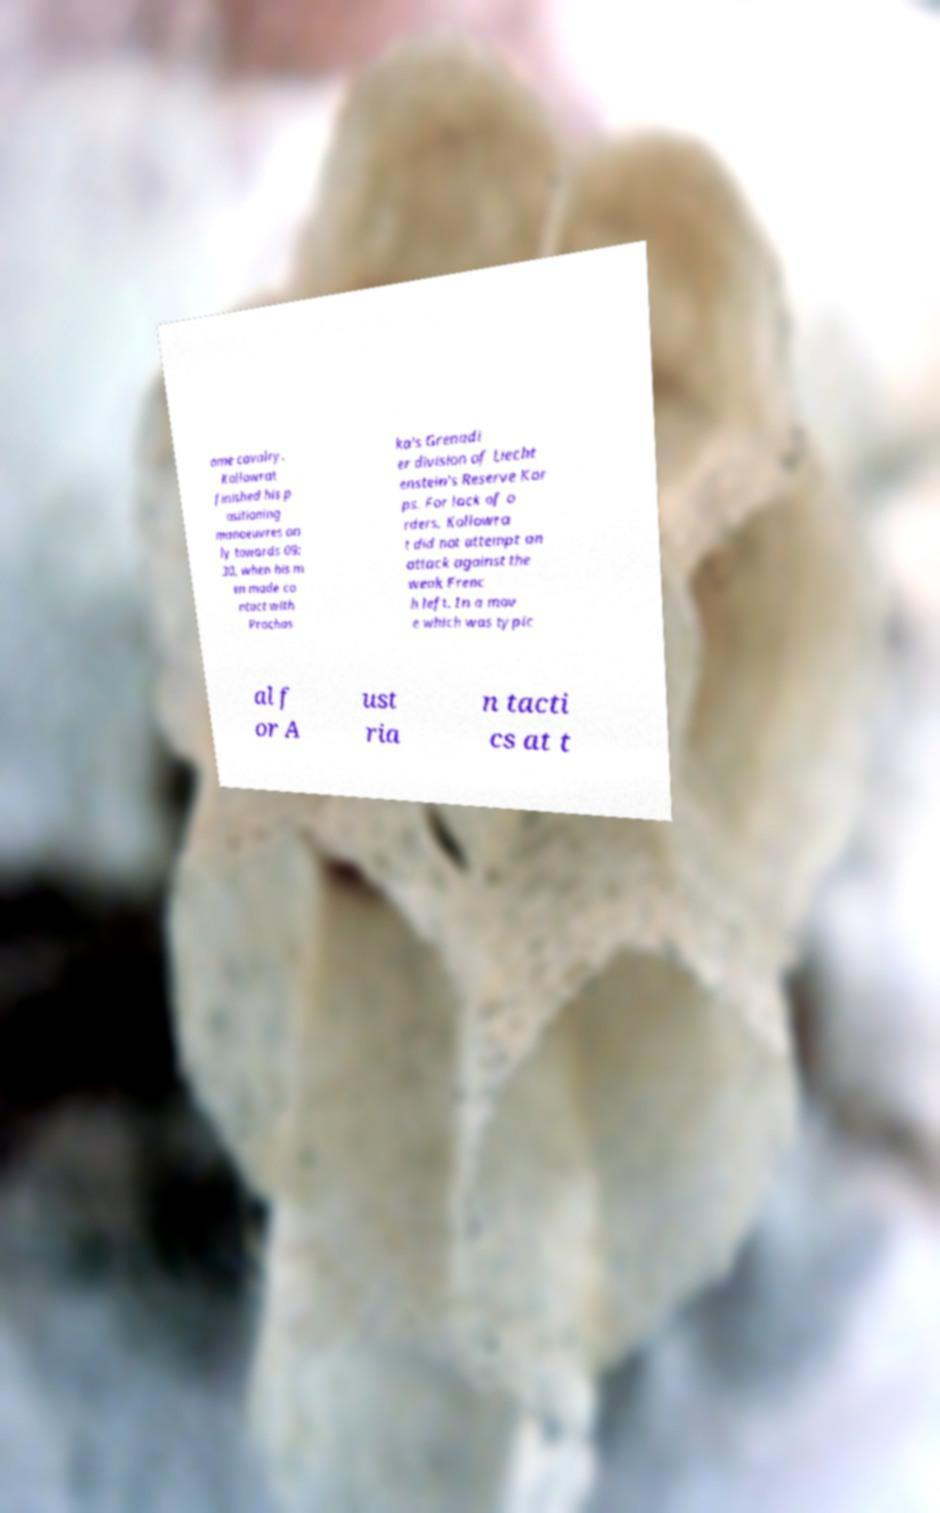Please identify and transcribe the text found in this image. ome cavalry. Kollowrat finished his p ositioning manoeuvres on ly towards 09: 30, when his m en made co ntact with Prochas ka's Grenadi er division of Liecht enstein's Reserve Kor ps. For lack of o rders, Kollowra t did not attempt an attack against the weak Frenc h left. In a mov e which was typic al f or A ust ria n tacti cs at t 